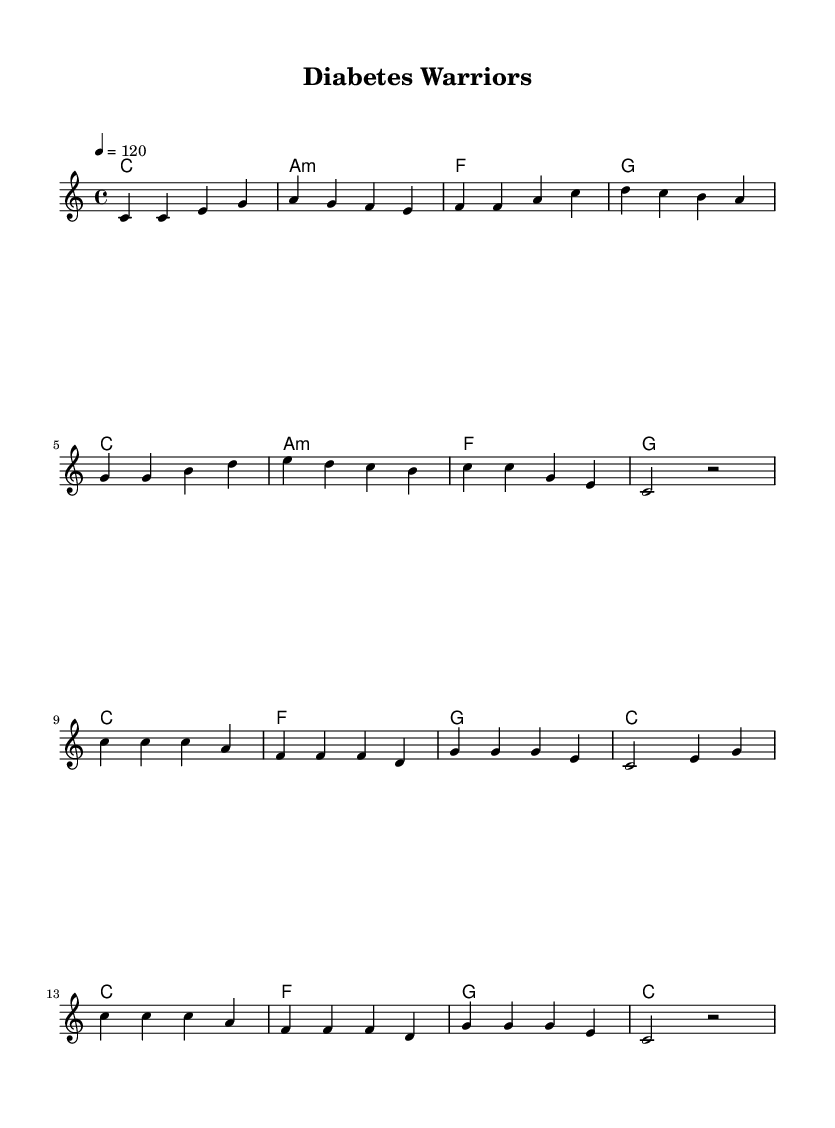What is the key signature of this music? The key signature is C major, which has no sharps or flats.
Answer: C major What is the time signature of this music? The time signature indicated in the sheet music is 4/4, which means there are 4 beats in a measure and the quarter note gets one beat.
Answer: 4/4 What is the tempo marking of this piece? The tempo marking specifies a speed of 120 beats per minute, indicated as "4 = 120" which means the quarter note is played at this speed.
Answer: 120 How many measures are in the verse section? The verse section consists of 8 measures, as counted by the sequences of notes shown in the melody part.
Answer: 8 What is the main theme of the chorus? The chorus emphasizes the idea of empowerment and teamwork in diabetes management, highlighted by the lyrics "We are diabetes warriors."
Answer: Diabetes warriors What chord follows the F major chord in the chorus? The chord progression shows that the G major chord follows the F major chord, which can be seen in the harmonic structure of the chorus.
Answer: G What is the last note of the melody in the chorus? The last note of the melody, as indicated, is *a*, which is the final note before the rest (pause) indicated in the last measure of the chorus.
Answer: a 